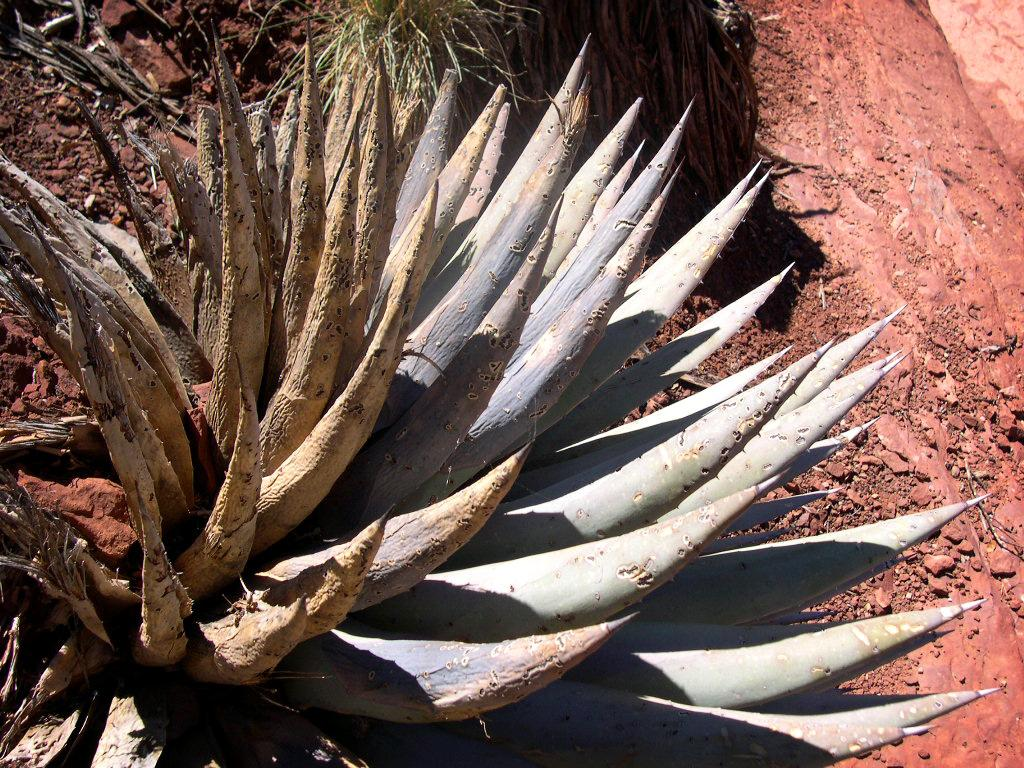What type of vegetation can be seen in the image? There are plants in the image. What type of ground cover is present in the image? There is grass in the image. What non-living object can be seen in the image? There is a brown-colored rock in the image. What type of pump is visible in the image? There is no pump present in the image. Is there a camera visible in the image? There is no camera present in the image. 